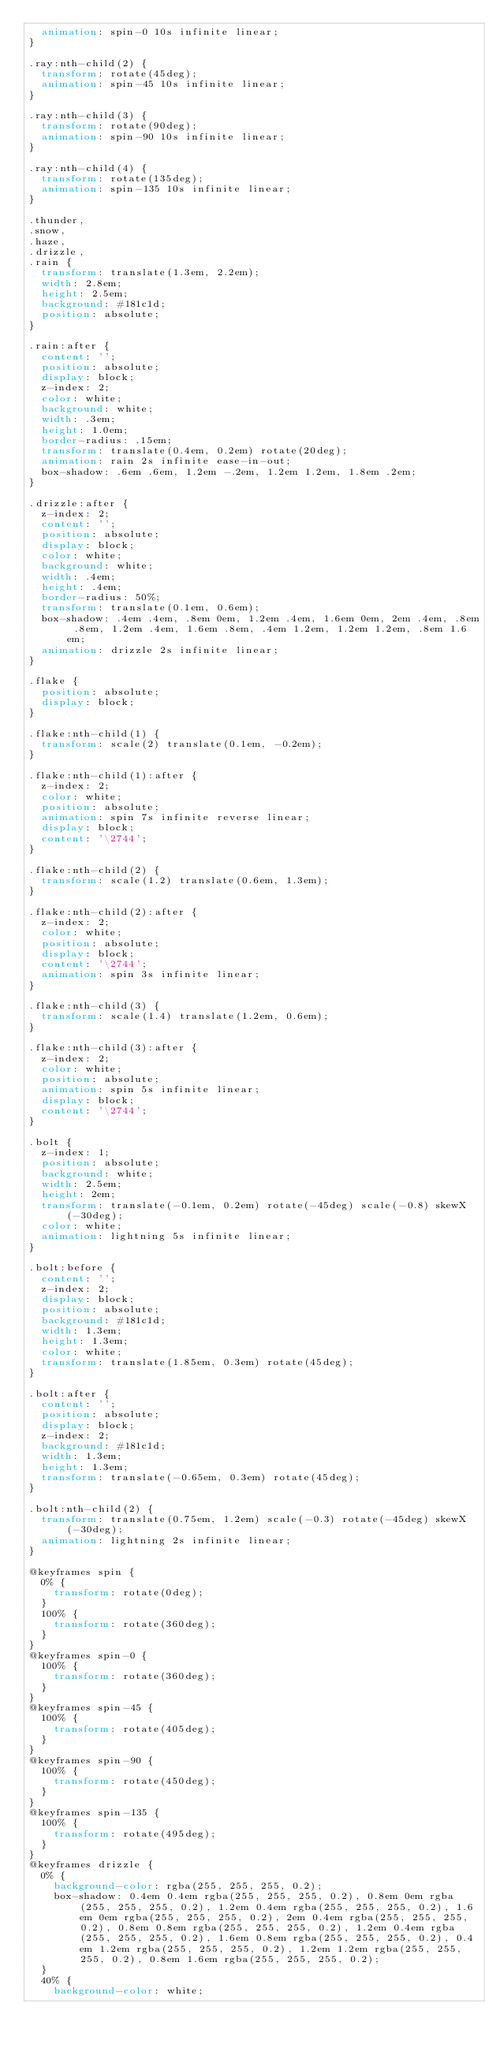<code> <loc_0><loc_0><loc_500><loc_500><_CSS_>  animation: spin-0 10s infinite linear;
}

.ray:nth-child(2) {
  transform: rotate(45deg);
  animation: spin-45 10s infinite linear;
}

.ray:nth-child(3) {
  transform: rotate(90deg);
  animation: spin-90 10s infinite linear;
}

.ray:nth-child(4) {
  transform: rotate(135deg);
  animation: spin-135 10s infinite linear;
}

.thunder,
.snow,
.haze,
.drizzle,
.rain {
  transform: translate(1.3em, 2.2em);
  width: 2.8em;
  height: 2.5em;
  background: #181c1d;
  position: absolute;
}

.rain:after {
  content: '';
  position: absolute;
  display: block;
  z-index: 2;
  color: white;
  background: white;
  width: .3em;
  height: 1.0em;
  border-radius: .15em;
  transform: translate(0.4em, 0.2em) rotate(20deg);
  animation: rain 2s infinite ease-in-out;
  box-shadow: .6em .6em, 1.2em -.2em, 1.2em 1.2em, 1.8em .2em;
}

.drizzle:after {
  z-index: 2;
  content: '';
  position: absolute;
  display: block;
  color: white;
  background: white;
  width: .4em;
  height: .4em;
  border-radius: 50%;
  transform: translate(0.1em, 0.6em);
  box-shadow: .4em .4em, .8em 0em, 1.2em .4em, 1.6em 0em, 2em .4em, .8em .8em, 1.2em .4em, 1.6em .8em, .4em 1.2em, 1.2em 1.2em, .8em 1.6em;
  animation: drizzle 2s infinite linear;
}

.flake {
  position: absolute;
  display: block;
}

.flake:nth-child(1) {
  transform: scale(2) translate(0.1em, -0.2em);
}

.flake:nth-child(1):after {
  z-index: 2;
  color: white;
  position: absolute;
  animation: spin 7s infinite reverse linear;
  display: block;
  content: '\2744';
}

.flake:nth-child(2) {
  transform: scale(1.2) translate(0.6em, 1.3em);
}

.flake:nth-child(2):after {
  z-index: 2;
  color: white;
  position: absolute;
  display: block;
  content: '\2744';
  animation: spin 3s infinite linear;
}

.flake:nth-child(3) {
  transform: scale(1.4) translate(1.2em, 0.6em);
}

.flake:nth-child(3):after {
  z-index: 2;
  color: white;
  position: absolute;
  animation: spin 5s infinite linear;
  display: block;
  content: '\2744';
}

.bolt {
  z-index: 1;
  position: absolute;
  background: white;
  width: 2.5em;
  height: 2em;
  transform: translate(-0.1em, 0.2em) rotate(-45deg) scale(-0.8) skewX(-30deg);
  color: white;
  animation: lightning 5s infinite linear;
}

.bolt:before {
  content: '';
  z-index: 2;
  display: block;
  position: absolute;
  background: #181c1d;
  width: 1.3em;
  height: 1.3em;
  color: white;
  transform: translate(1.85em, 0.3em) rotate(45deg);
}

.bolt:after {
  content: '';
  position: absolute;
  display: block;
  z-index: 2;
  background: #181c1d;
  width: 1.3em;
  height: 1.3em;
  transform: translate(-0.65em, 0.3em) rotate(45deg);
}

.bolt:nth-child(2) {
  transform: translate(0.75em, 1.2em) scale(-0.3) rotate(-45deg) skewX(-30deg);
  animation: lightning 2s infinite linear;
}

@keyframes spin {
  0% {
    transform: rotate(0deg);
  }
  100% {
    transform: rotate(360deg);
  }
}
@keyframes spin-0 {
  100% {
    transform: rotate(360deg);
  }
}
@keyframes spin-45 {
  100% {
    transform: rotate(405deg);
  }
}
@keyframes spin-90 {
  100% {
    transform: rotate(450deg);
  }
}
@keyframes spin-135 {
  100% {
    transform: rotate(495deg);
  }
}
@keyframes drizzle {
  0% {
    background-color: rgba(255, 255, 255, 0.2);
    box-shadow: 0.4em 0.4em rgba(255, 255, 255, 0.2), 0.8em 0em rgba(255, 255, 255, 0.2), 1.2em 0.4em rgba(255, 255, 255, 0.2), 1.6em 0em rgba(255, 255, 255, 0.2), 2em 0.4em rgba(255, 255, 255, 0.2), 0.8em 0.8em rgba(255, 255, 255, 0.2), 1.2em 0.4em rgba(255, 255, 255, 0.2), 1.6em 0.8em rgba(255, 255, 255, 0.2), 0.4em 1.2em rgba(255, 255, 255, 0.2), 1.2em 1.2em rgba(255, 255, 255, 0.2), 0.8em 1.6em rgba(255, 255, 255, 0.2);
  }
  40% {
    background-color: white;</code> 